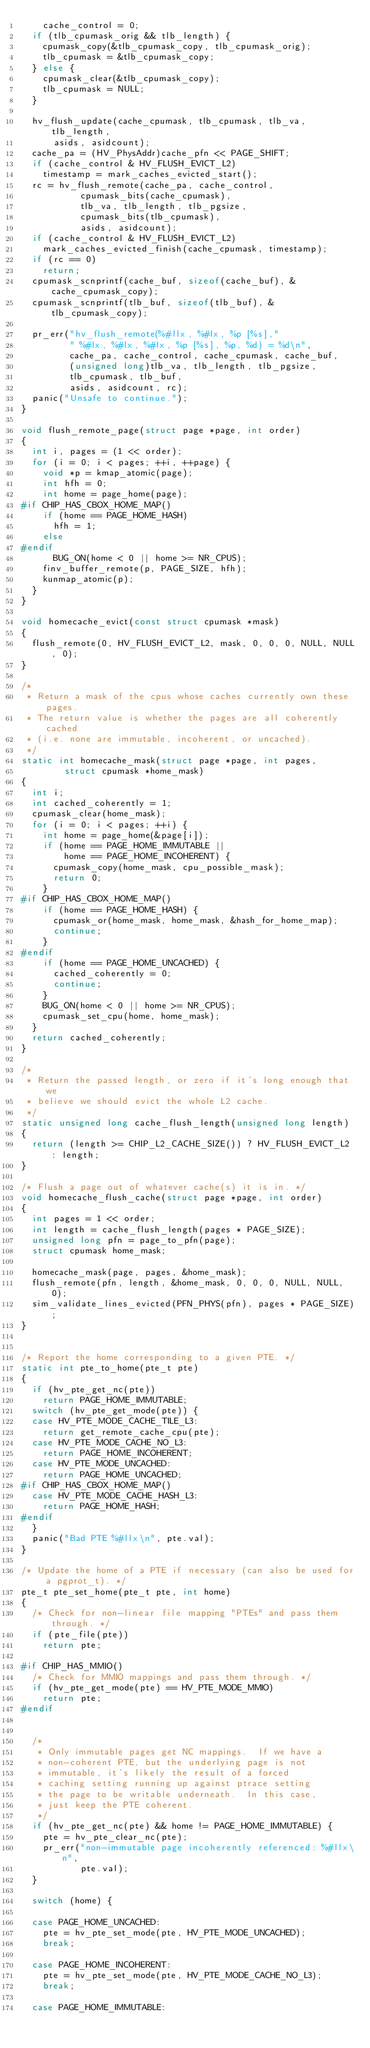Convert code to text. <code><loc_0><loc_0><loc_500><loc_500><_C_>		cache_control = 0;
	if (tlb_cpumask_orig && tlb_length) {
		cpumask_copy(&tlb_cpumask_copy, tlb_cpumask_orig);
		tlb_cpumask = &tlb_cpumask_copy;
	} else {
		cpumask_clear(&tlb_cpumask_copy);
		tlb_cpumask = NULL;
	}

	hv_flush_update(cache_cpumask, tlb_cpumask, tlb_va, tlb_length,
			asids, asidcount);
	cache_pa = (HV_PhysAddr)cache_pfn << PAGE_SHIFT;
	if (cache_control & HV_FLUSH_EVICT_L2)
		timestamp = mark_caches_evicted_start();
	rc = hv_flush_remote(cache_pa, cache_control,
			     cpumask_bits(cache_cpumask),
			     tlb_va, tlb_length, tlb_pgsize,
			     cpumask_bits(tlb_cpumask),
			     asids, asidcount);
	if (cache_control & HV_FLUSH_EVICT_L2)
		mark_caches_evicted_finish(cache_cpumask, timestamp);
	if (rc == 0)
		return;
	cpumask_scnprintf(cache_buf, sizeof(cache_buf), &cache_cpumask_copy);
	cpumask_scnprintf(tlb_buf, sizeof(tlb_buf), &tlb_cpumask_copy);

	pr_err("hv_flush_remote(%#llx, %#lx, %p [%s],"
	       " %#lx, %#lx, %#lx, %p [%s], %p, %d) = %d\n",
	       cache_pa, cache_control, cache_cpumask, cache_buf,
	       (unsigned long)tlb_va, tlb_length, tlb_pgsize,
	       tlb_cpumask, tlb_buf,
	       asids, asidcount, rc);
	panic("Unsafe to continue.");
}

void flush_remote_page(struct page *page, int order)
{
	int i, pages = (1 << order);
	for (i = 0; i < pages; ++i, ++page) {
		void *p = kmap_atomic(page);
		int hfh = 0;
		int home = page_home(page);
#if CHIP_HAS_CBOX_HOME_MAP()
		if (home == PAGE_HOME_HASH)
			hfh = 1;
		else
#endif
			BUG_ON(home < 0 || home >= NR_CPUS);
		finv_buffer_remote(p, PAGE_SIZE, hfh);
		kunmap_atomic(p);
	}
}

void homecache_evict(const struct cpumask *mask)
{
	flush_remote(0, HV_FLUSH_EVICT_L2, mask, 0, 0, 0, NULL, NULL, 0);
}

/*
 * Return a mask of the cpus whose caches currently own these pages.
 * The return value is whether the pages are all coherently cached
 * (i.e. none are immutable, incoherent, or uncached).
 */
static int homecache_mask(struct page *page, int pages,
			  struct cpumask *home_mask)
{
	int i;
	int cached_coherently = 1;
	cpumask_clear(home_mask);
	for (i = 0; i < pages; ++i) {
		int home = page_home(&page[i]);
		if (home == PAGE_HOME_IMMUTABLE ||
		    home == PAGE_HOME_INCOHERENT) {
			cpumask_copy(home_mask, cpu_possible_mask);
			return 0;
		}
#if CHIP_HAS_CBOX_HOME_MAP()
		if (home == PAGE_HOME_HASH) {
			cpumask_or(home_mask, home_mask, &hash_for_home_map);
			continue;
		}
#endif
		if (home == PAGE_HOME_UNCACHED) {
			cached_coherently = 0;
			continue;
		}
		BUG_ON(home < 0 || home >= NR_CPUS);
		cpumask_set_cpu(home, home_mask);
	}
	return cached_coherently;
}

/*
 * Return the passed length, or zero if it's long enough that we
 * believe we should evict the whole L2 cache.
 */
static unsigned long cache_flush_length(unsigned long length)
{
	return (length >= CHIP_L2_CACHE_SIZE()) ? HV_FLUSH_EVICT_L2 : length;
}

/* Flush a page out of whatever cache(s) it is in. */
void homecache_flush_cache(struct page *page, int order)
{
	int pages = 1 << order;
	int length = cache_flush_length(pages * PAGE_SIZE);
	unsigned long pfn = page_to_pfn(page);
	struct cpumask home_mask;

	homecache_mask(page, pages, &home_mask);
	flush_remote(pfn, length, &home_mask, 0, 0, 0, NULL, NULL, 0);
	sim_validate_lines_evicted(PFN_PHYS(pfn), pages * PAGE_SIZE);
}


/* Report the home corresponding to a given PTE. */
static int pte_to_home(pte_t pte)
{
	if (hv_pte_get_nc(pte))
		return PAGE_HOME_IMMUTABLE;
	switch (hv_pte_get_mode(pte)) {
	case HV_PTE_MODE_CACHE_TILE_L3:
		return get_remote_cache_cpu(pte);
	case HV_PTE_MODE_CACHE_NO_L3:
		return PAGE_HOME_INCOHERENT;
	case HV_PTE_MODE_UNCACHED:
		return PAGE_HOME_UNCACHED;
#if CHIP_HAS_CBOX_HOME_MAP()
	case HV_PTE_MODE_CACHE_HASH_L3:
		return PAGE_HOME_HASH;
#endif
	}
	panic("Bad PTE %#llx\n", pte.val);
}

/* Update the home of a PTE if necessary (can also be used for a pgprot_t). */
pte_t pte_set_home(pte_t pte, int home)
{
	/* Check for non-linear file mapping "PTEs" and pass them through. */
	if (pte_file(pte))
		return pte;

#if CHIP_HAS_MMIO()
	/* Check for MMIO mappings and pass them through. */
	if (hv_pte_get_mode(pte) == HV_PTE_MODE_MMIO)
		return pte;
#endif


	/*
	 * Only immutable pages get NC mappings.  If we have a
	 * non-coherent PTE, but the underlying page is not
	 * immutable, it's likely the result of a forced
	 * caching setting running up against ptrace setting
	 * the page to be writable underneath.  In this case,
	 * just keep the PTE coherent.
	 */
	if (hv_pte_get_nc(pte) && home != PAGE_HOME_IMMUTABLE) {
		pte = hv_pte_clear_nc(pte);
		pr_err("non-immutable page incoherently referenced: %#llx\n",
		       pte.val);
	}

	switch (home) {

	case PAGE_HOME_UNCACHED:
		pte = hv_pte_set_mode(pte, HV_PTE_MODE_UNCACHED);
		break;

	case PAGE_HOME_INCOHERENT:
		pte = hv_pte_set_mode(pte, HV_PTE_MODE_CACHE_NO_L3);
		break;

	case PAGE_HOME_IMMUTABLE:</code> 